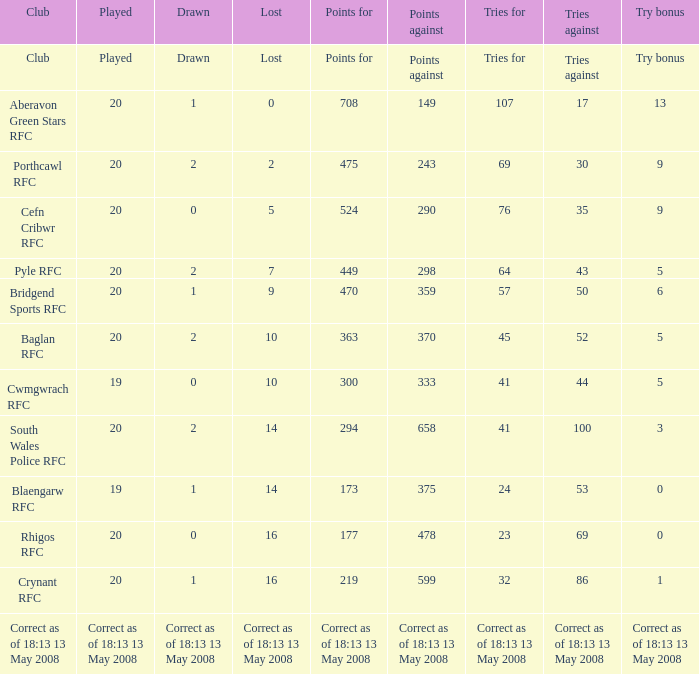What are the points when the try bonus equals 1? 219.0. Could you parse the entire table? {'header': ['Club', 'Played', 'Drawn', 'Lost', 'Points for', 'Points against', 'Tries for', 'Tries against', 'Try bonus'], 'rows': [['Club', 'Played', 'Drawn', 'Lost', 'Points for', 'Points against', 'Tries for', 'Tries against', 'Try bonus'], ['Aberavon Green Stars RFC', '20', '1', '0', '708', '149', '107', '17', '13'], ['Porthcawl RFC', '20', '2', '2', '475', '243', '69', '30', '9'], ['Cefn Cribwr RFC', '20', '0', '5', '524', '290', '76', '35', '9'], ['Pyle RFC', '20', '2', '7', '449', '298', '64', '43', '5'], ['Bridgend Sports RFC', '20', '1', '9', '470', '359', '57', '50', '6'], ['Baglan RFC', '20', '2', '10', '363', '370', '45', '52', '5'], ['Cwmgwrach RFC', '19', '0', '10', '300', '333', '41', '44', '5'], ['South Wales Police RFC', '20', '2', '14', '294', '658', '41', '100', '3'], ['Blaengarw RFC', '19', '1', '14', '173', '375', '24', '53', '0'], ['Rhigos RFC', '20', '0', '16', '177', '478', '23', '69', '0'], ['Crynant RFC', '20', '1', '16', '219', '599', '32', '86', '1'], ['Correct as of 18:13 13 May 2008', 'Correct as of 18:13 13 May 2008', 'Correct as of 18:13 13 May 2008', 'Correct as of 18:13 13 May 2008', 'Correct as of 18:13 13 May 2008', 'Correct as of 18:13 13 May 2008', 'Correct as of 18:13 13 May 2008', 'Correct as of 18:13 13 May 2008', 'Correct as of 18:13 13 May 2008']]} 